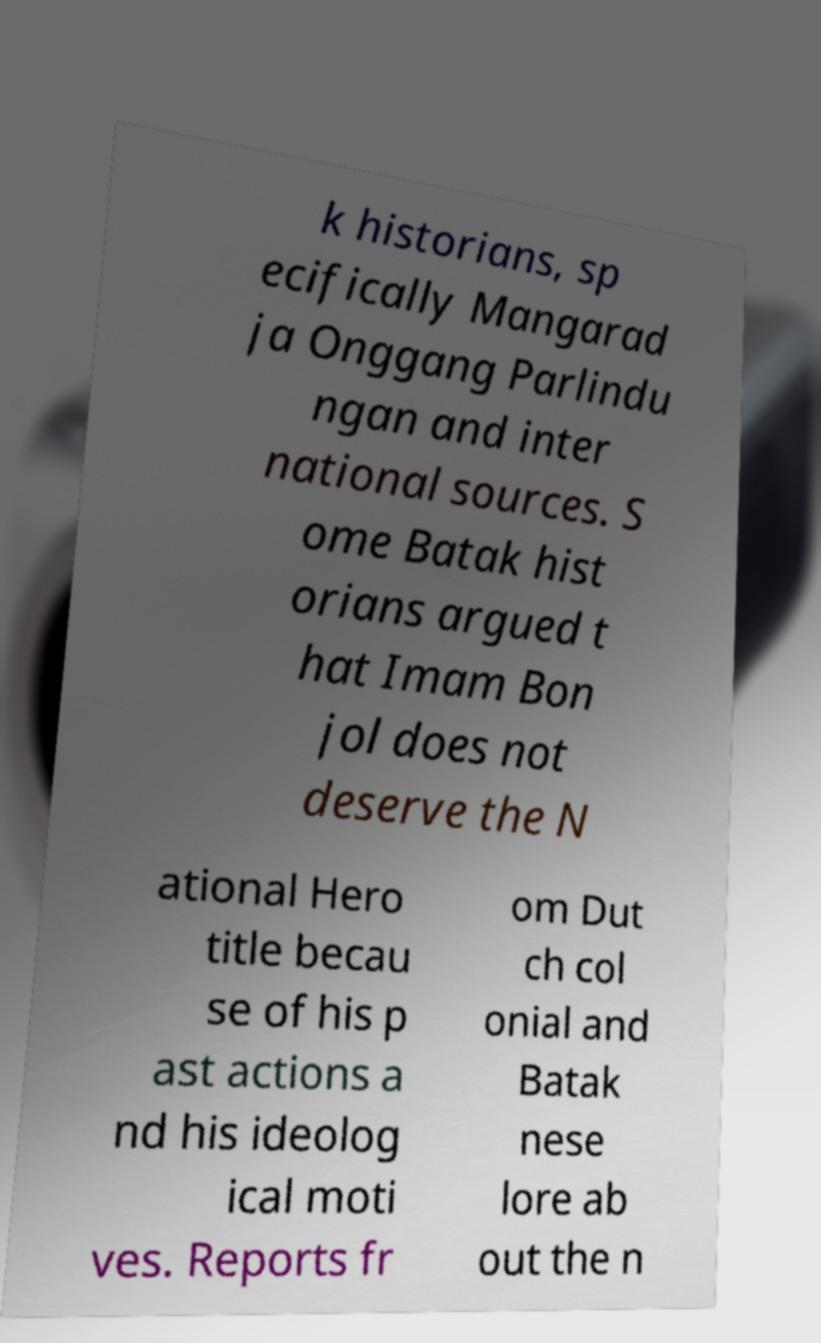Can you read and provide the text displayed in the image?This photo seems to have some interesting text. Can you extract and type it out for me? k historians, sp ecifically Mangarad ja Onggang Parlindu ngan and inter national sources. S ome Batak hist orians argued t hat Imam Bon jol does not deserve the N ational Hero title becau se of his p ast actions a nd his ideolog ical moti ves. Reports fr om Dut ch col onial and Batak nese lore ab out the n 